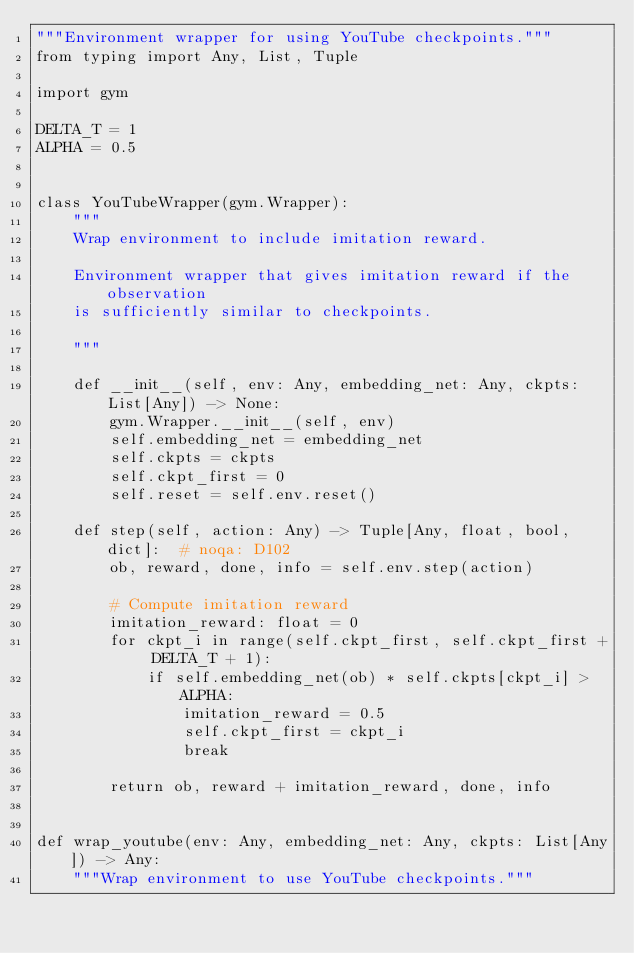Convert code to text. <code><loc_0><loc_0><loc_500><loc_500><_Python_>"""Environment wrapper for using YouTube checkpoints."""
from typing import Any, List, Tuple

import gym

DELTA_T = 1
ALPHA = 0.5


class YouTubeWrapper(gym.Wrapper):
    """
    Wrap environment to include imitation reward.

    Environment wrapper that gives imitation reward if the observation
    is sufficiently similar to checkpoints.

    """

    def __init__(self, env: Any, embedding_net: Any, ckpts: List[Any]) -> None:
        gym.Wrapper.__init__(self, env)
        self.embedding_net = embedding_net
        self.ckpts = ckpts
        self.ckpt_first = 0
        self.reset = self.env.reset()

    def step(self, action: Any) -> Tuple[Any, float, bool, dict]:  # noqa: D102
        ob, reward, done, info = self.env.step(action)

        # Compute imitation reward
        imitation_reward: float = 0
        for ckpt_i in range(self.ckpt_first, self.ckpt_first + DELTA_T + 1):
            if self.embedding_net(ob) * self.ckpts[ckpt_i] > ALPHA:
                imitation_reward = 0.5
                self.ckpt_first = ckpt_i
                break

        return ob, reward + imitation_reward, done, info


def wrap_youtube(env: Any, embedding_net: Any, ckpts: List[Any]) -> Any:
    """Wrap environment to use YouTube checkpoints."""</code> 